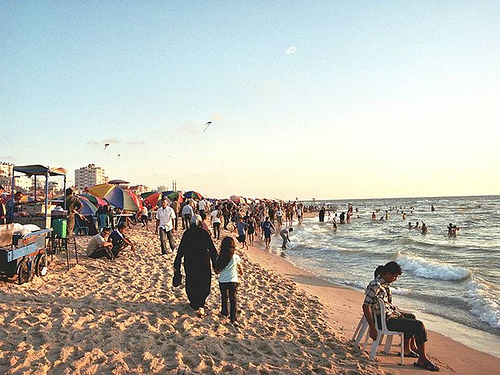Is the blue cart to the left or to the right of the people on the left? The blue cart is positioned to the left of the people who are gathered towards the left side of the beach, providing a reference point in the crowd. 